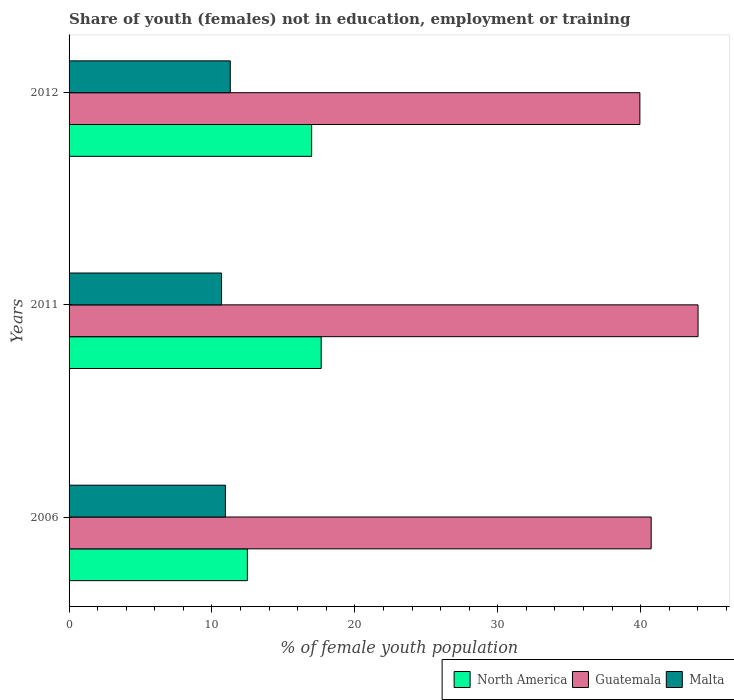Are the number of bars on each tick of the Y-axis equal?
Your answer should be very brief. Yes. How many bars are there on the 3rd tick from the bottom?
Provide a succinct answer. 3. What is the label of the 3rd group of bars from the top?
Offer a very short reply. 2006. In how many cases, is the number of bars for a given year not equal to the number of legend labels?
Provide a succinct answer. 0. What is the percentage of unemployed female population in in North America in 2012?
Your response must be concise. 16.97. Across all years, what is the maximum percentage of unemployed female population in in Guatemala?
Offer a terse response. 44.01. Across all years, what is the minimum percentage of unemployed female population in in Guatemala?
Give a very brief answer. 39.94. What is the total percentage of unemployed female population in in Malta in the graph?
Give a very brief answer. 32.89. What is the difference between the percentage of unemployed female population in in Malta in 2006 and that in 2012?
Ensure brevity in your answer.  -0.34. What is the difference between the percentage of unemployed female population in in Malta in 2006 and the percentage of unemployed female population in in North America in 2011?
Make the answer very short. -6.7. What is the average percentage of unemployed female population in in Malta per year?
Provide a succinct answer. 10.96. In the year 2012, what is the difference between the percentage of unemployed female population in in North America and percentage of unemployed female population in in Malta?
Offer a very short reply. 5.69. What is the ratio of the percentage of unemployed female population in in Malta in 2011 to that in 2012?
Your response must be concise. 0.95. Is the percentage of unemployed female population in in Malta in 2011 less than that in 2012?
Make the answer very short. Yes. What is the difference between the highest and the second highest percentage of unemployed female population in in Malta?
Offer a very short reply. 0.34. What is the difference between the highest and the lowest percentage of unemployed female population in in Malta?
Keep it short and to the point. 0.61. In how many years, is the percentage of unemployed female population in in Malta greater than the average percentage of unemployed female population in in Malta taken over all years?
Ensure brevity in your answer.  1. What does the 3rd bar from the top in 2006 represents?
Your answer should be compact. North America. What does the 2nd bar from the bottom in 2006 represents?
Provide a short and direct response. Guatemala. How many bars are there?
Make the answer very short. 9. Are the values on the major ticks of X-axis written in scientific E-notation?
Offer a very short reply. No. Does the graph contain grids?
Your response must be concise. No. How many legend labels are there?
Your answer should be compact. 3. What is the title of the graph?
Provide a succinct answer. Share of youth (females) not in education, employment or training. Does "Belarus" appear as one of the legend labels in the graph?
Keep it short and to the point. No. What is the label or title of the X-axis?
Provide a succinct answer. % of female youth population. What is the % of female youth population in North America in 2006?
Give a very brief answer. 12.48. What is the % of female youth population in Guatemala in 2006?
Offer a very short reply. 40.73. What is the % of female youth population in Malta in 2006?
Give a very brief answer. 10.94. What is the % of female youth population of North America in 2011?
Offer a very short reply. 17.64. What is the % of female youth population of Guatemala in 2011?
Provide a succinct answer. 44.01. What is the % of female youth population of Malta in 2011?
Give a very brief answer. 10.67. What is the % of female youth population in North America in 2012?
Give a very brief answer. 16.97. What is the % of female youth population of Guatemala in 2012?
Ensure brevity in your answer.  39.94. What is the % of female youth population of Malta in 2012?
Offer a very short reply. 11.28. Across all years, what is the maximum % of female youth population of North America?
Make the answer very short. 17.64. Across all years, what is the maximum % of female youth population in Guatemala?
Your response must be concise. 44.01. Across all years, what is the maximum % of female youth population of Malta?
Offer a very short reply. 11.28. Across all years, what is the minimum % of female youth population in North America?
Keep it short and to the point. 12.48. Across all years, what is the minimum % of female youth population of Guatemala?
Ensure brevity in your answer.  39.94. Across all years, what is the minimum % of female youth population of Malta?
Provide a succinct answer. 10.67. What is the total % of female youth population of North America in the graph?
Your response must be concise. 47.09. What is the total % of female youth population of Guatemala in the graph?
Keep it short and to the point. 124.68. What is the total % of female youth population in Malta in the graph?
Give a very brief answer. 32.89. What is the difference between the % of female youth population in North America in 2006 and that in 2011?
Provide a succinct answer. -5.16. What is the difference between the % of female youth population of Guatemala in 2006 and that in 2011?
Provide a succinct answer. -3.28. What is the difference between the % of female youth population of Malta in 2006 and that in 2011?
Your answer should be compact. 0.27. What is the difference between the % of female youth population of North America in 2006 and that in 2012?
Make the answer very short. -4.5. What is the difference between the % of female youth population of Guatemala in 2006 and that in 2012?
Your answer should be compact. 0.79. What is the difference between the % of female youth population in Malta in 2006 and that in 2012?
Ensure brevity in your answer.  -0.34. What is the difference between the % of female youth population in North America in 2011 and that in 2012?
Ensure brevity in your answer.  0.67. What is the difference between the % of female youth population of Guatemala in 2011 and that in 2012?
Provide a succinct answer. 4.07. What is the difference between the % of female youth population in Malta in 2011 and that in 2012?
Your answer should be very brief. -0.61. What is the difference between the % of female youth population of North America in 2006 and the % of female youth population of Guatemala in 2011?
Your response must be concise. -31.53. What is the difference between the % of female youth population of North America in 2006 and the % of female youth population of Malta in 2011?
Make the answer very short. 1.81. What is the difference between the % of female youth population in Guatemala in 2006 and the % of female youth population in Malta in 2011?
Ensure brevity in your answer.  30.06. What is the difference between the % of female youth population of North America in 2006 and the % of female youth population of Guatemala in 2012?
Ensure brevity in your answer.  -27.46. What is the difference between the % of female youth population of North America in 2006 and the % of female youth population of Malta in 2012?
Provide a short and direct response. 1.2. What is the difference between the % of female youth population of Guatemala in 2006 and the % of female youth population of Malta in 2012?
Provide a succinct answer. 29.45. What is the difference between the % of female youth population in North America in 2011 and the % of female youth population in Guatemala in 2012?
Keep it short and to the point. -22.3. What is the difference between the % of female youth population in North America in 2011 and the % of female youth population in Malta in 2012?
Your answer should be very brief. 6.36. What is the difference between the % of female youth population in Guatemala in 2011 and the % of female youth population in Malta in 2012?
Keep it short and to the point. 32.73. What is the average % of female youth population in North America per year?
Give a very brief answer. 15.7. What is the average % of female youth population of Guatemala per year?
Offer a terse response. 41.56. What is the average % of female youth population of Malta per year?
Keep it short and to the point. 10.96. In the year 2006, what is the difference between the % of female youth population of North America and % of female youth population of Guatemala?
Provide a succinct answer. -28.25. In the year 2006, what is the difference between the % of female youth population of North America and % of female youth population of Malta?
Ensure brevity in your answer.  1.54. In the year 2006, what is the difference between the % of female youth population in Guatemala and % of female youth population in Malta?
Give a very brief answer. 29.79. In the year 2011, what is the difference between the % of female youth population of North America and % of female youth population of Guatemala?
Make the answer very short. -26.37. In the year 2011, what is the difference between the % of female youth population of North America and % of female youth population of Malta?
Provide a succinct answer. 6.97. In the year 2011, what is the difference between the % of female youth population in Guatemala and % of female youth population in Malta?
Keep it short and to the point. 33.34. In the year 2012, what is the difference between the % of female youth population of North America and % of female youth population of Guatemala?
Offer a terse response. -22.97. In the year 2012, what is the difference between the % of female youth population in North America and % of female youth population in Malta?
Provide a short and direct response. 5.69. In the year 2012, what is the difference between the % of female youth population in Guatemala and % of female youth population in Malta?
Provide a succinct answer. 28.66. What is the ratio of the % of female youth population in North America in 2006 to that in 2011?
Ensure brevity in your answer.  0.71. What is the ratio of the % of female youth population of Guatemala in 2006 to that in 2011?
Give a very brief answer. 0.93. What is the ratio of the % of female youth population of Malta in 2006 to that in 2011?
Keep it short and to the point. 1.03. What is the ratio of the % of female youth population of North America in 2006 to that in 2012?
Your answer should be very brief. 0.73. What is the ratio of the % of female youth population of Guatemala in 2006 to that in 2012?
Keep it short and to the point. 1.02. What is the ratio of the % of female youth population in Malta in 2006 to that in 2012?
Your response must be concise. 0.97. What is the ratio of the % of female youth population in North America in 2011 to that in 2012?
Give a very brief answer. 1.04. What is the ratio of the % of female youth population of Guatemala in 2011 to that in 2012?
Your response must be concise. 1.1. What is the ratio of the % of female youth population in Malta in 2011 to that in 2012?
Give a very brief answer. 0.95. What is the difference between the highest and the second highest % of female youth population in North America?
Give a very brief answer. 0.67. What is the difference between the highest and the second highest % of female youth population of Guatemala?
Provide a succinct answer. 3.28. What is the difference between the highest and the second highest % of female youth population in Malta?
Give a very brief answer. 0.34. What is the difference between the highest and the lowest % of female youth population of North America?
Keep it short and to the point. 5.16. What is the difference between the highest and the lowest % of female youth population of Guatemala?
Provide a short and direct response. 4.07. What is the difference between the highest and the lowest % of female youth population of Malta?
Provide a short and direct response. 0.61. 